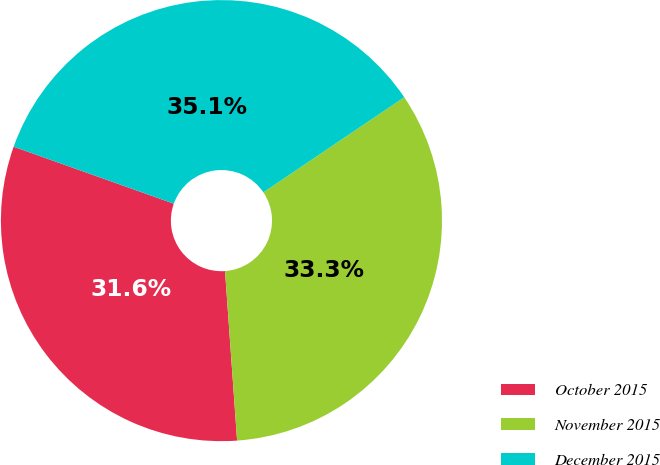Convert chart. <chart><loc_0><loc_0><loc_500><loc_500><pie_chart><fcel>October 2015<fcel>November 2015<fcel>December 2015<nl><fcel>31.57%<fcel>33.32%<fcel>35.11%<nl></chart> 